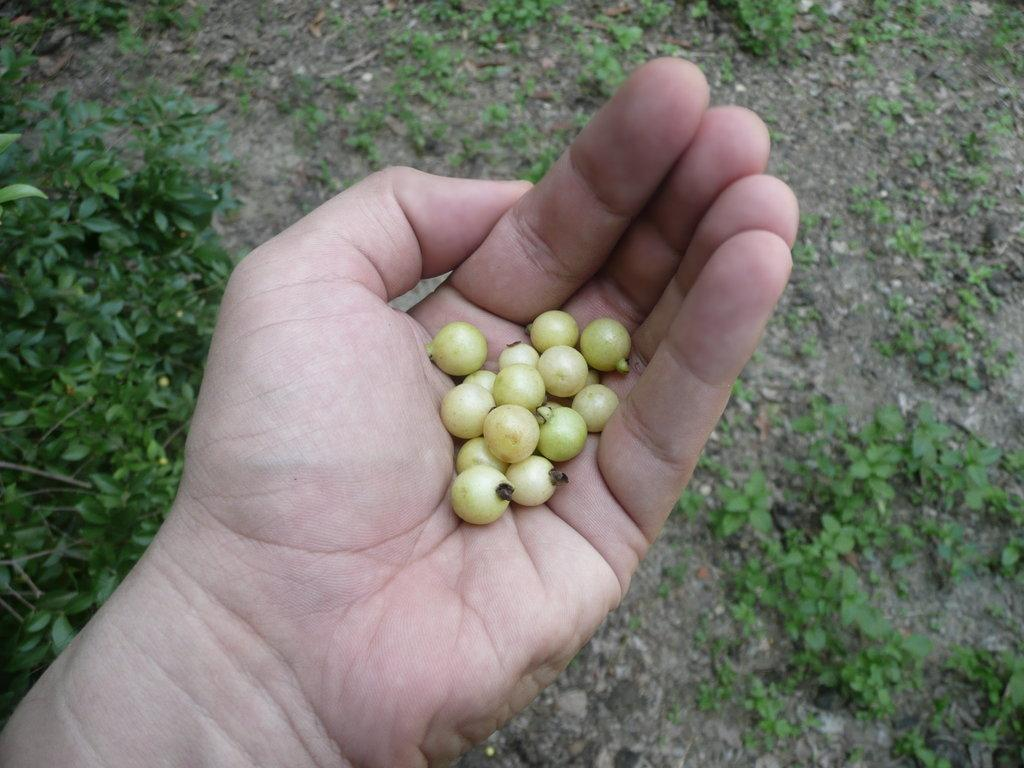Who or what is present in the image? There is a person in the image. What is the person holding in their hand? The person is holding food items in their hand. What type of vegetation can be seen on the ground in the image? There are green plants on the ground in the image. What type of ornament is hanging from the person's jeans in the image? There is no ornament hanging from the person's jeans in the image, nor are there any jeans present. 